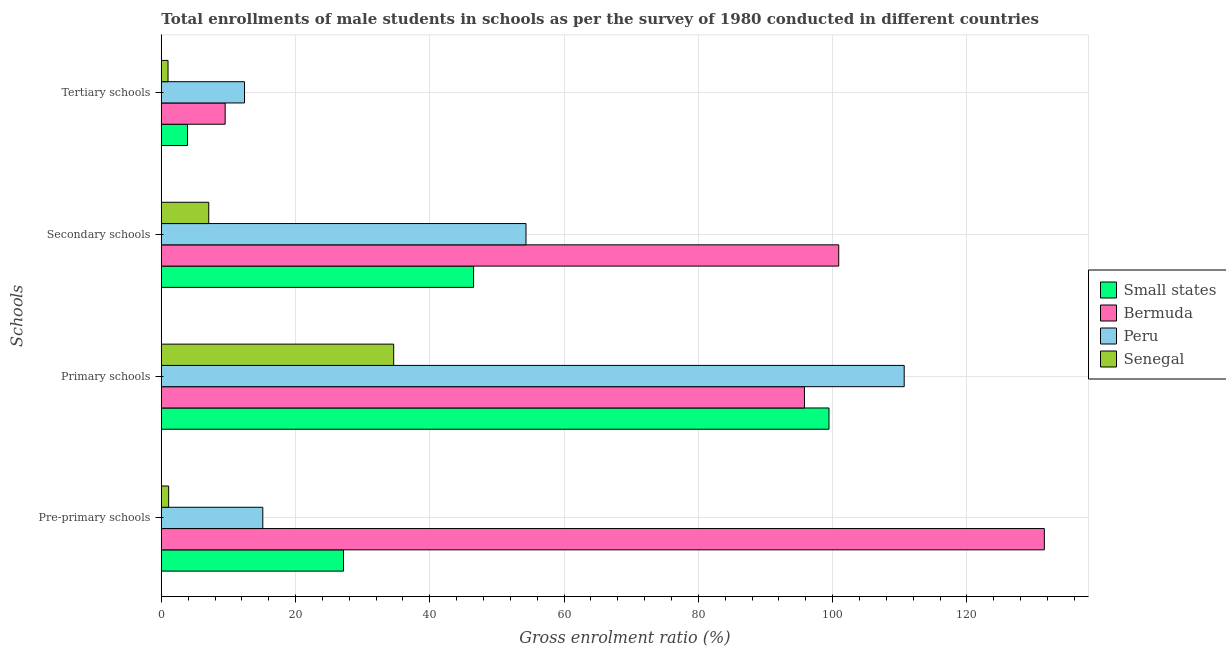How many different coloured bars are there?
Your answer should be very brief. 4. Are the number of bars on each tick of the Y-axis equal?
Keep it short and to the point. Yes. How many bars are there on the 1st tick from the top?
Offer a very short reply. 4. How many bars are there on the 3rd tick from the bottom?
Your answer should be very brief. 4. What is the label of the 1st group of bars from the top?
Provide a succinct answer. Tertiary schools. What is the gross enrolment ratio(male) in tertiary schools in Small states?
Provide a succinct answer. 3.9. Across all countries, what is the maximum gross enrolment ratio(male) in secondary schools?
Provide a short and direct response. 100.91. Across all countries, what is the minimum gross enrolment ratio(male) in secondary schools?
Make the answer very short. 7.07. In which country was the gross enrolment ratio(male) in primary schools minimum?
Provide a succinct answer. Senegal. What is the total gross enrolment ratio(male) in pre-primary schools in the graph?
Keep it short and to the point. 174.89. What is the difference between the gross enrolment ratio(male) in tertiary schools in Small states and that in Senegal?
Give a very brief answer. 2.9. What is the difference between the gross enrolment ratio(male) in secondary schools in Senegal and the gross enrolment ratio(male) in primary schools in Peru?
Your response must be concise. -103.6. What is the average gross enrolment ratio(male) in pre-primary schools per country?
Ensure brevity in your answer.  43.72. What is the difference between the gross enrolment ratio(male) in tertiary schools and gross enrolment ratio(male) in primary schools in Bermuda?
Ensure brevity in your answer.  -86.3. In how many countries, is the gross enrolment ratio(male) in pre-primary schools greater than 124 %?
Make the answer very short. 1. What is the ratio of the gross enrolment ratio(male) in primary schools in Senegal to that in Bermuda?
Give a very brief answer. 0.36. Is the gross enrolment ratio(male) in primary schools in Peru less than that in Small states?
Your answer should be compact. No. What is the difference between the highest and the second highest gross enrolment ratio(male) in secondary schools?
Your answer should be compact. 46.59. What is the difference between the highest and the lowest gross enrolment ratio(male) in secondary schools?
Keep it short and to the point. 93.85. In how many countries, is the gross enrolment ratio(male) in pre-primary schools greater than the average gross enrolment ratio(male) in pre-primary schools taken over all countries?
Offer a terse response. 1. Is it the case that in every country, the sum of the gross enrolment ratio(male) in primary schools and gross enrolment ratio(male) in pre-primary schools is greater than the sum of gross enrolment ratio(male) in tertiary schools and gross enrolment ratio(male) in secondary schools?
Provide a succinct answer. Yes. What does the 3rd bar from the top in Primary schools represents?
Offer a very short reply. Bermuda. What does the 2nd bar from the bottom in Primary schools represents?
Your answer should be compact. Bermuda. How many bars are there?
Give a very brief answer. 16. What is the difference between two consecutive major ticks on the X-axis?
Your response must be concise. 20. How many legend labels are there?
Ensure brevity in your answer.  4. What is the title of the graph?
Keep it short and to the point. Total enrollments of male students in schools as per the survey of 1980 conducted in different countries. Does "Iran" appear as one of the legend labels in the graph?
Keep it short and to the point. No. What is the label or title of the X-axis?
Offer a terse response. Gross enrolment ratio (%). What is the label or title of the Y-axis?
Ensure brevity in your answer.  Schools. What is the Gross enrolment ratio (%) of Small states in Pre-primary schools?
Ensure brevity in your answer.  27.14. What is the Gross enrolment ratio (%) in Bermuda in Pre-primary schools?
Provide a succinct answer. 131.54. What is the Gross enrolment ratio (%) in Peru in Pre-primary schools?
Provide a succinct answer. 15.12. What is the Gross enrolment ratio (%) in Senegal in Pre-primary schools?
Ensure brevity in your answer.  1.09. What is the Gross enrolment ratio (%) in Small states in Primary schools?
Your answer should be very brief. 99.46. What is the Gross enrolment ratio (%) in Bermuda in Primary schools?
Your response must be concise. 95.81. What is the Gross enrolment ratio (%) of Peru in Primary schools?
Your answer should be compact. 110.67. What is the Gross enrolment ratio (%) in Senegal in Primary schools?
Provide a short and direct response. 34.62. What is the Gross enrolment ratio (%) of Small states in Secondary schools?
Keep it short and to the point. 46.52. What is the Gross enrolment ratio (%) of Bermuda in Secondary schools?
Offer a very short reply. 100.91. What is the Gross enrolment ratio (%) in Peru in Secondary schools?
Keep it short and to the point. 54.33. What is the Gross enrolment ratio (%) of Senegal in Secondary schools?
Your answer should be compact. 7.07. What is the Gross enrolment ratio (%) in Small states in Tertiary schools?
Offer a very short reply. 3.9. What is the Gross enrolment ratio (%) of Bermuda in Tertiary schools?
Give a very brief answer. 9.51. What is the Gross enrolment ratio (%) in Peru in Tertiary schools?
Ensure brevity in your answer.  12.4. What is the Gross enrolment ratio (%) in Senegal in Tertiary schools?
Make the answer very short. 1. Across all Schools, what is the maximum Gross enrolment ratio (%) in Small states?
Your answer should be very brief. 99.46. Across all Schools, what is the maximum Gross enrolment ratio (%) of Bermuda?
Ensure brevity in your answer.  131.54. Across all Schools, what is the maximum Gross enrolment ratio (%) of Peru?
Keep it short and to the point. 110.67. Across all Schools, what is the maximum Gross enrolment ratio (%) in Senegal?
Your answer should be very brief. 34.62. Across all Schools, what is the minimum Gross enrolment ratio (%) of Small states?
Your response must be concise. 3.9. Across all Schools, what is the minimum Gross enrolment ratio (%) of Bermuda?
Your answer should be compact. 9.51. Across all Schools, what is the minimum Gross enrolment ratio (%) in Peru?
Offer a very short reply. 12.4. Across all Schools, what is the minimum Gross enrolment ratio (%) in Senegal?
Make the answer very short. 1. What is the total Gross enrolment ratio (%) of Small states in the graph?
Make the answer very short. 177.02. What is the total Gross enrolment ratio (%) of Bermuda in the graph?
Ensure brevity in your answer.  337.77. What is the total Gross enrolment ratio (%) in Peru in the graph?
Offer a terse response. 192.51. What is the total Gross enrolment ratio (%) in Senegal in the graph?
Offer a very short reply. 43.78. What is the difference between the Gross enrolment ratio (%) in Small states in Pre-primary schools and that in Primary schools?
Ensure brevity in your answer.  -72.32. What is the difference between the Gross enrolment ratio (%) of Bermuda in Pre-primary schools and that in Primary schools?
Make the answer very short. 35.73. What is the difference between the Gross enrolment ratio (%) in Peru in Pre-primary schools and that in Primary schools?
Give a very brief answer. -95.55. What is the difference between the Gross enrolment ratio (%) in Senegal in Pre-primary schools and that in Primary schools?
Your answer should be compact. -33.52. What is the difference between the Gross enrolment ratio (%) of Small states in Pre-primary schools and that in Secondary schools?
Your answer should be very brief. -19.38. What is the difference between the Gross enrolment ratio (%) in Bermuda in Pre-primary schools and that in Secondary schools?
Make the answer very short. 30.63. What is the difference between the Gross enrolment ratio (%) in Peru in Pre-primary schools and that in Secondary schools?
Ensure brevity in your answer.  -39.21. What is the difference between the Gross enrolment ratio (%) in Senegal in Pre-primary schools and that in Secondary schools?
Give a very brief answer. -5.97. What is the difference between the Gross enrolment ratio (%) of Small states in Pre-primary schools and that in Tertiary schools?
Ensure brevity in your answer.  23.24. What is the difference between the Gross enrolment ratio (%) of Bermuda in Pre-primary schools and that in Tertiary schools?
Offer a terse response. 122.03. What is the difference between the Gross enrolment ratio (%) of Peru in Pre-primary schools and that in Tertiary schools?
Your response must be concise. 2.72. What is the difference between the Gross enrolment ratio (%) in Senegal in Pre-primary schools and that in Tertiary schools?
Give a very brief answer. 0.09. What is the difference between the Gross enrolment ratio (%) of Small states in Primary schools and that in Secondary schools?
Make the answer very short. 52.94. What is the difference between the Gross enrolment ratio (%) in Bermuda in Primary schools and that in Secondary schools?
Provide a short and direct response. -5.11. What is the difference between the Gross enrolment ratio (%) of Peru in Primary schools and that in Secondary schools?
Your response must be concise. 56.34. What is the difference between the Gross enrolment ratio (%) in Senegal in Primary schools and that in Secondary schools?
Offer a very short reply. 27.55. What is the difference between the Gross enrolment ratio (%) in Small states in Primary schools and that in Tertiary schools?
Offer a very short reply. 95.56. What is the difference between the Gross enrolment ratio (%) of Bermuda in Primary schools and that in Tertiary schools?
Make the answer very short. 86.3. What is the difference between the Gross enrolment ratio (%) in Peru in Primary schools and that in Tertiary schools?
Keep it short and to the point. 98.27. What is the difference between the Gross enrolment ratio (%) of Senegal in Primary schools and that in Tertiary schools?
Offer a terse response. 33.62. What is the difference between the Gross enrolment ratio (%) of Small states in Secondary schools and that in Tertiary schools?
Give a very brief answer. 42.62. What is the difference between the Gross enrolment ratio (%) of Bermuda in Secondary schools and that in Tertiary schools?
Ensure brevity in your answer.  91.4. What is the difference between the Gross enrolment ratio (%) in Peru in Secondary schools and that in Tertiary schools?
Keep it short and to the point. 41.93. What is the difference between the Gross enrolment ratio (%) in Senegal in Secondary schools and that in Tertiary schools?
Provide a succinct answer. 6.07. What is the difference between the Gross enrolment ratio (%) of Small states in Pre-primary schools and the Gross enrolment ratio (%) of Bermuda in Primary schools?
Give a very brief answer. -68.67. What is the difference between the Gross enrolment ratio (%) of Small states in Pre-primary schools and the Gross enrolment ratio (%) of Peru in Primary schools?
Your answer should be compact. -83.53. What is the difference between the Gross enrolment ratio (%) of Small states in Pre-primary schools and the Gross enrolment ratio (%) of Senegal in Primary schools?
Your answer should be very brief. -7.48. What is the difference between the Gross enrolment ratio (%) in Bermuda in Pre-primary schools and the Gross enrolment ratio (%) in Peru in Primary schools?
Give a very brief answer. 20.88. What is the difference between the Gross enrolment ratio (%) in Bermuda in Pre-primary schools and the Gross enrolment ratio (%) in Senegal in Primary schools?
Give a very brief answer. 96.93. What is the difference between the Gross enrolment ratio (%) in Peru in Pre-primary schools and the Gross enrolment ratio (%) in Senegal in Primary schools?
Provide a short and direct response. -19.5. What is the difference between the Gross enrolment ratio (%) in Small states in Pre-primary schools and the Gross enrolment ratio (%) in Bermuda in Secondary schools?
Make the answer very short. -73.77. What is the difference between the Gross enrolment ratio (%) in Small states in Pre-primary schools and the Gross enrolment ratio (%) in Peru in Secondary schools?
Make the answer very short. -27.19. What is the difference between the Gross enrolment ratio (%) in Small states in Pre-primary schools and the Gross enrolment ratio (%) in Senegal in Secondary schools?
Provide a short and direct response. 20.07. What is the difference between the Gross enrolment ratio (%) in Bermuda in Pre-primary schools and the Gross enrolment ratio (%) in Peru in Secondary schools?
Offer a very short reply. 77.22. What is the difference between the Gross enrolment ratio (%) in Bermuda in Pre-primary schools and the Gross enrolment ratio (%) in Senegal in Secondary schools?
Make the answer very short. 124.48. What is the difference between the Gross enrolment ratio (%) of Peru in Pre-primary schools and the Gross enrolment ratio (%) of Senegal in Secondary schools?
Keep it short and to the point. 8.05. What is the difference between the Gross enrolment ratio (%) in Small states in Pre-primary schools and the Gross enrolment ratio (%) in Bermuda in Tertiary schools?
Make the answer very short. 17.63. What is the difference between the Gross enrolment ratio (%) in Small states in Pre-primary schools and the Gross enrolment ratio (%) in Peru in Tertiary schools?
Make the answer very short. 14.74. What is the difference between the Gross enrolment ratio (%) of Small states in Pre-primary schools and the Gross enrolment ratio (%) of Senegal in Tertiary schools?
Offer a terse response. 26.14. What is the difference between the Gross enrolment ratio (%) in Bermuda in Pre-primary schools and the Gross enrolment ratio (%) in Peru in Tertiary schools?
Your answer should be very brief. 119.15. What is the difference between the Gross enrolment ratio (%) in Bermuda in Pre-primary schools and the Gross enrolment ratio (%) in Senegal in Tertiary schools?
Give a very brief answer. 130.54. What is the difference between the Gross enrolment ratio (%) in Peru in Pre-primary schools and the Gross enrolment ratio (%) in Senegal in Tertiary schools?
Your response must be concise. 14.12. What is the difference between the Gross enrolment ratio (%) of Small states in Primary schools and the Gross enrolment ratio (%) of Bermuda in Secondary schools?
Your answer should be very brief. -1.45. What is the difference between the Gross enrolment ratio (%) in Small states in Primary schools and the Gross enrolment ratio (%) in Peru in Secondary schools?
Your response must be concise. 45.13. What is the difference between the Gross enrolment ratio (%) of Small states in Primary schools and the Gross enrolment ratio (%) of Senegal in Secondary schools?
Offer a terse response. 92.39. What is the difference between the Gross enrolment ratio (%) of Bermuda in Primary schools and the Gross enrolment ratio (%) of Peru in Secondary schools?
Ensure brevity in your answer.  41.48. What is the difference between the Gross enrolment ratio (%) of Bermuda in Primary schools and the Gross enrolment ratio (%) of Senegal in Secondary schools?
Offer a very short reply. 88.74. What is the difference between the Gross enrolment ratio (%) of Peru in Primary schools and the Gross enrolment ratio (%) of Senegal in Secondary schools?
Keep it short and to the point. 103.6. What is the difference between the Gross enrolment ratio (%) of Small states in Primary schools and the Gross enrolment ratio (%) of Bermuda in Tertiary schools?
Give a very brief answer. 89.95. What is the difference between the Gross enrolment ratio (%) in Small states in Primary schools and the Gross enrolment ratio (%) in Peru in Tertiary schools?
Provide a succinct answer. 87.06. What is the difference between the Gross enrolment ratio (%) of Small states in Primary schools and the Gross enrolment ratio (%) of Senegal in Tertiary schools?
Give a very brief answer. 98.46. What is the difference between the Gross enrolment ratio (%) in Bermuda in Primary schools and the Gross enrolment ratio (%) in Peru in Tertiary schools?
Give a very brief answer. 83.41. What is the difference between the Gross enrolment ratio (%) in Bermuda in Primary schools and the Gross enrolment ratio (%) in Senegal in Tertiary schools?
Offer a terse response. 94.81. What is the difference between the Gross enrolment ratio (%) in Peru in Primary schools and the Gross enrolment ratio (%) in Senegal in Tertiary schools?
Your answer should be very brief. 109.67. What is the difference between the Gross enrolment ratio (%) in Small states in Secondary schools and the Gross enrolment ratio (%) in Bermuda in Tertiary schools?
Make the answer very short. 37.01. What is the difference between the Gross enrolment ratio (%) of Small states in Secondary schools and the Gross enrolment ratio (%) of Peru in Tertiary schools?
Make the answer very short. 34.12. What is the difference between the Gross enrolment ratio (%) in Small states in Secondary schools and the Gross enrolment ratio (%) in Senegal in Tertiary schools?
Provide a short and direct response. 45.52. What is the difference between the Gross enrolment ratio (%) in Bermuda in Secondary schools and the Gross enrolment ratio (%) in Peru in Tertiary schools?
Make the answer very short. 88.52. What is the difference between the Gross enrolment ratio (%) of Bermuda in Secondary schools and the Gross enrolment ratio (%) of Senegal in Tertiary schools?
Make the answer very short. 99.91. What is the difference between the Gross enrolment ratio (%) in Peru in Secondary schools and the Gross enrolment ratio (%) in Senegal in Tertiary schools?
Ensure brevity in your answer.  53.33. What is the average Gross enrolment ratio (%) in Small states per Schools?
Provide a short and direct response. 44.25. What is the average Gross enrolment ratio (%) of Bermuda per Schools?
Your answer should be compact. 84.44. What is the average Gross enrolment ratio (%) of Peru per Schools?
Provide a short and direct response. 48.13. What is the average Gross enrolment ratio (%) in Senegal per Schools?
Offer a terse response. 10.94. What is the difference between the Gross enrolment ratio (%) in Small states and Gross enrolment ratio (%) in Bermuda in Pre-primary schools?
Your answer should be very brief. -104.4. What is the difference between the Gross enrolment ratio (%) of Small states and Gross enrolment ratio (%) of Peru in Pre-primary schools?
Keep it short and to the point. 12.02. What is the difference between the Gross enrolment ratio (%) in Small states and Gross enrolment ratio (%) in Senegal in Pre-primary schools?
Make the answer very short. 26.05. What is the difference between the Gross enrolment ratio (%) in Bermuda and Gross enrolment ratio (%) in Peru in Pre-primary schools?
Keep it short and to the point. 116.42. What is the difference between the Gross enrolment ratio (%) of Bermuda and Gross enrolment ratio (%) of Senegal in Pre-primary schools?
Your answer should be very brief. 130.45. What is the difference between the Gross enrolment ratio (%) of Peru and Gross enrolment ratio (%) of Senegal in Pre-primary schools?
Your answer should be very brief. 14.02. What is the difference between the Gross enrolment ratio (%) in Small states and Gross enrolment ratio (%) in Bermuda in Primary schools?
Your answer should be compact. 3.65. What is the difference between the Gross enrolment ratio (%) in Small states and Gross enrolment ratio (%) in Peru in Primary schools?
Offer a very short reply. -11.21. What is the difference between the Gross enrolment ratio (%) in Small states and Gross enrolment ratio (%) in Senegal in Primary schools?
Offer a terse response. 64.84. What is the difference between the Gross enrolment ratio (%) of Bermuda and Gross enrolment ratio (%) of Peru in Primary schools?
Make the answer very short. -14.86. What is the difference between the Gross enrolment ratio (%) of Bermuda and Gross enrolment ratio (%) of Senegal in Primary schools?
Your response must be concise. 61.19. What is the difference between the Gross enrolment ratio (%) in Peru and Gross enrolment ratio (%) in Senegal in Primary schools?
Provide a short and direct response. 76.05. What is the difference between the Gross enrolment ratio (%) of Small states and Gross enrolment ratio (%) of Bermuda in Secondary schools?
Provide a succinct answer. -54.4. What is the difference between the Gross enrolment ratio (%) of Small states and Gross enrolment ratio (%) of Peru in Secondary schools?
Give a very brief answer. -7.81. What is the difference between the Gross enrolment ratio (%) in Small states and Gross enrolment ratio (%) in Senegal in Secondary schools?
Your response must be concise. 39.45. What is the difference between the Gross enrolment ratio (%) in Bermuda and Gross enrolment ratio (%) in Peru in Secondary schools?
Make the answer very short. 46.59. What is the difference between the Gross enrolment ratio (%) in Bermuda and Gross enrolment ratio (%) in Senegal in Secondary schools?
Provide a succinct answer. 93.85. What is the difference between the Gross enrolment ratio (%) in Peru and Gross enrolment ratio (%) in Senegal in Secondary schools?
Your answer should be very brief. 47.26. What is the difference between the Gross enrolment ratio (%) of Small states and Gross enrolment ratio (%) of Bermuda in Tertiary schools?
Your response must be concise. -5.61. What is the difference between the Gross enrolment ratio (%) of Small states and Gross enrolment ratio (%) of Peru in Tertiary schools?
Make the answer very short. -8.5. What is the difference between the Gross enrolment ratio (%) in Small states and Gross enrolment ratio (%) in Senegal in Tertiary schools?
Keep it short and to the point. 2.9. What is the difference between the Gross enrolment ratio (%) in Bermuda and Gross enrolment ratio (%) in Peru in Tertiary schools?
Provide a short and direct response. -2.89. What is the difference between the Gross enrolment ratio (%) in Bermuda and Gross enrolment ratio (%) in Senegal in Tertiary schools?
Offer a terse response. 8.51. What is the difference between the Gross enrolment ratio (%) in Peru and Gross enrolment ratio (%) in Senegal in Tertiary schools?
Offer a very short reply. 11.4. What is the ratio of the Gross enrolment ratio (%) of Small states in Pre-primary schools to that in Primary schools?
Make the answer very short. 0.27. What is the ratio of the Gross enrolment ratio (%) in Bermuda in Pre-primary schools to that in Primary schools?
Keep it short and to the point. 1.37. What is the ratio of the Gross enrolment ratio (%) of Peru in Pre-primary schools to that in Primary schools?
Your response must be concise. 0.14. What is the ratio of the Gross enrolment ratio (%) of Senegal in Pre-primary schools to that in Primary schools?
Your response must be concise. 0.03. What is the ratio of the Gross enrolment ratio (%) in Small states in Pre-primary schools to that in Secondary schools?
Make the answer very short. 0.58. What is the ratio of the Gross enrolment ratio (%) of Bermuda in Pre-primary schools to that in Secondary schools?
Keep it short and to the point. 1.3. What is the ratio of the Gross enrolment ratio (%) of Peru in Pre-primary schools to that in Secondary schools?
Give a very brief answer. 0.28. What is the ratio of the Gross enrolment ratio (%) in Senegal in Pre-primary schools to that in Secondary schools?
Keep it short and to the point. 0.15. What is the ratio of the Gross enrolment ratio (%) in Small states in Pre-primary schools to that in Tertiary schools?
Give a very brief answer. 6.96. What is the ratio of the Gross enrolment ratio (%) of Bermuda in Pre-primary schools to that in Tertiary schools?
Make the answer very short. 13.83. What is the ratio of the Gross enrolment ratio (%) in Peru in Pre-primary schools to that in Tertiary schools?
Make the answer very short. 1.22. What is the ratio of the Gross enrolment ratio (%) of Senegal in Pre-primary schools to that in Tertiary schools?
Provide a succinct answer. 1.09. What is the ratio of the Gross enrolment ratio (%) of Small states in Primary schools to that in Secondary schools?
Your response must be concise. 2.14. What is the ratio of the Gross enrolment ratio (%) of Bermuda in Primary schools to that in Secondary schools?
Your response must be concise. 0.95. What is the ratio of the Gross enrolment ratio (%) of Peru in Primary schools to that in Secondary schools?
Your answer should be compact. 2.04. What is the ratio of the Gross enrolment ratio (%) in Senegal in Primary schools to that in Secondary schools?
Your answer should be very brief. 4.9. What is the ratio of the Gross enrolment ratio (%) of Small states in Primary schools to that in Tertiary schools?
Offer a very short reply. 25.5. What is the ratio of the Gross enrolment ratio (%) of Bermuda in Primary schools to that in Tertiary schools?
Your answer should be compact. 10.07. What is the ratio of the Gross enrolment ratio (%) in Peru in Primary schools to that in Tertiary schools?
Your answer should be very brief. 8.93. What is the ratio of the Gross enrolment ratio (%) in Senegal in Primary schools to that in Tertiary schools?
Your answer should be very brief. 34.62. What is the ratio of the Gross enrolment ratio (%) in Small states in Secondary schools to that in Tertiary schools?
Your response must be concise. 11.93. What is the ratio of the Gross enrolment ratio (%) in Bermuda in Secondary schools to that in Tertiary schools?
Provide a short and direct response. 10.61. What is the ratio of the Gross enrolment ratio (%) in Peru in Secondary schools to that in Tertiary schools?
Ensure brevity in your answer.  4.38. What is the ratio of the Gross enrolment ratio (%) in Senegal in Secondary schools to that in Tertiary schools?
Provide a succinct answer. 7.07. What is the difference between the highest and the second highest Gross enrolment ratio (%) of Small states?
Ensure brevity in your answer.  52.94. What is the difference between the highest and the second highest Gross enrolment ratio (%) of Bermuda?
Give a very brief answer. 30.63. What is the difference between the highest and the second highest Gross enrolment ratio (%) in Peru?
Give a very brief answer. 56.34. What is the difference between the highest and the second highest Gross enrolment ratio (%) of Senegal?
Offer a terse response. 27.55. What is the difference between the highest and the lowest Gross enrolment ratio (%) in Small states?
Offer a very short reply. 95.56. What is the difference between the highest and the lowest Gross enrolment ratio (%) of Bermuda?
Give a very brief answer. 122.03. What is the difference between the highest and the lowest Gross enrolment ratio (%) in Peru?
Give a very brief answer. 98.27. What is the difference between the highest and the lowest Gross enrolment ratio (%) of Senegal?
Ensure brevity in your answer.  33.62. 